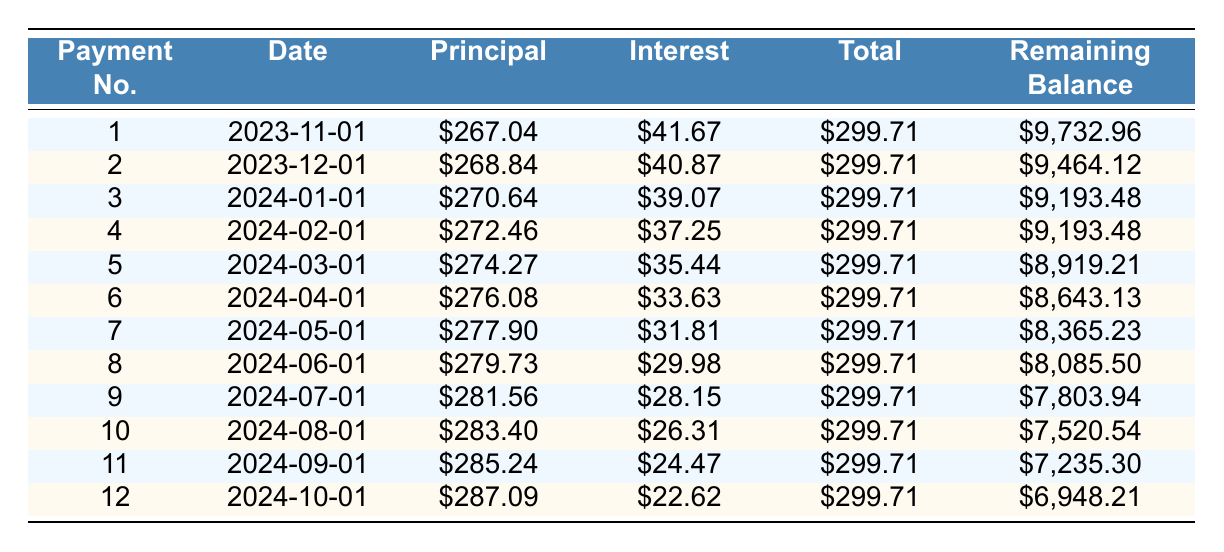What is the total amount paid at the end of the first month? The total payment for the first month is listed in the total payment column for payment number one, which is $299.71
Answer: 299.71 What was the principal payment made in the fifth month? The principal payment for the fifth month can be seen under principal payment in the row corresponding to payment number five, which is $274.27
Answer: 274.27 What is the remaining balance after three months? To find the remaining balance after three months, we look at the remaining balance column for payment number three, which shows $9,193.48
Answer: 9193.48 Is the interest payment lower in the tenth month than in the second month? For the tenth month, the interest payment is $26.31, and for the second month, it is $40.87. Since $26.31 is lower than $40.87, the statement is true
Answer: Yes What is the average monthly principal payment over the entire loan term? To calculate the average monthly principal payment, we need to sum up all the principal payments from the table, which totals $3,286.52, and divide by 12 months (3 years): $3,286.52 / 12 = $273.88
Answer: 273.88 What is the difference between the highest and lowest principal payments made in the payment schedule? The highest principal payment is in the twelfth month at $287.09, and the lowest is in the first month at $267.04. The difference is $287.09 - $267.04 = $20.05
Answer: 20.05 By how much does the total payment amount remain constant throughout the loan term? The total payment is the same every month, listed as $299.71 across all months, indicating that it remains constant at $299.71
Answer: Remains constant How much total interest will be paid over the first six months? The total interest payment over the first six months is found by adding the interest payments from the first to the sixth month: $41.67 + $40.87 + $39.07 + $37.25 + $35.44 + $33.63 = $227.93
Answer: 227.93 What is the remaining balance after the sixth payment? The remaining balance after the sixth payment is located in the remaining balance column corresponding to payment number six, which is $8,643.13
Answer: 8643.13 